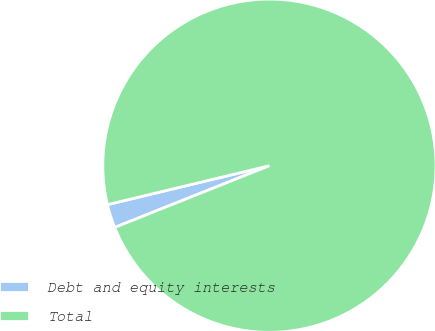Convert chart to OTSL. <chart><loc_0><loc_0><loc_500><loc_500><pie_chart><fcel>Debt and equity interests<fcel>Total<nl><fcel>2.29%<fcel>97.71%<nl></chart> 